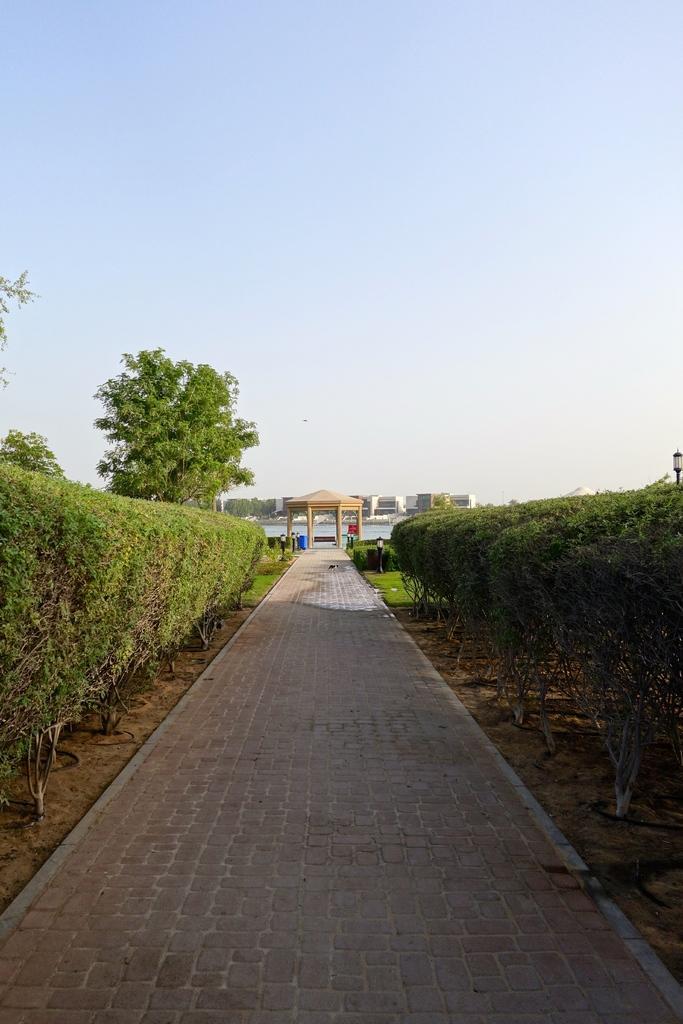Could you give a brief overview of what you see in this image? In the middle of the picture, we see the pavement. On either side of the picture, we see shrubs for hedging plants. On the right side, we see a light pole. On the left side, we see the trees. In the middle of the picture, we see an arch. Behind that, we see water. There are trees and buildings in the background. At the top, we see the sky. 